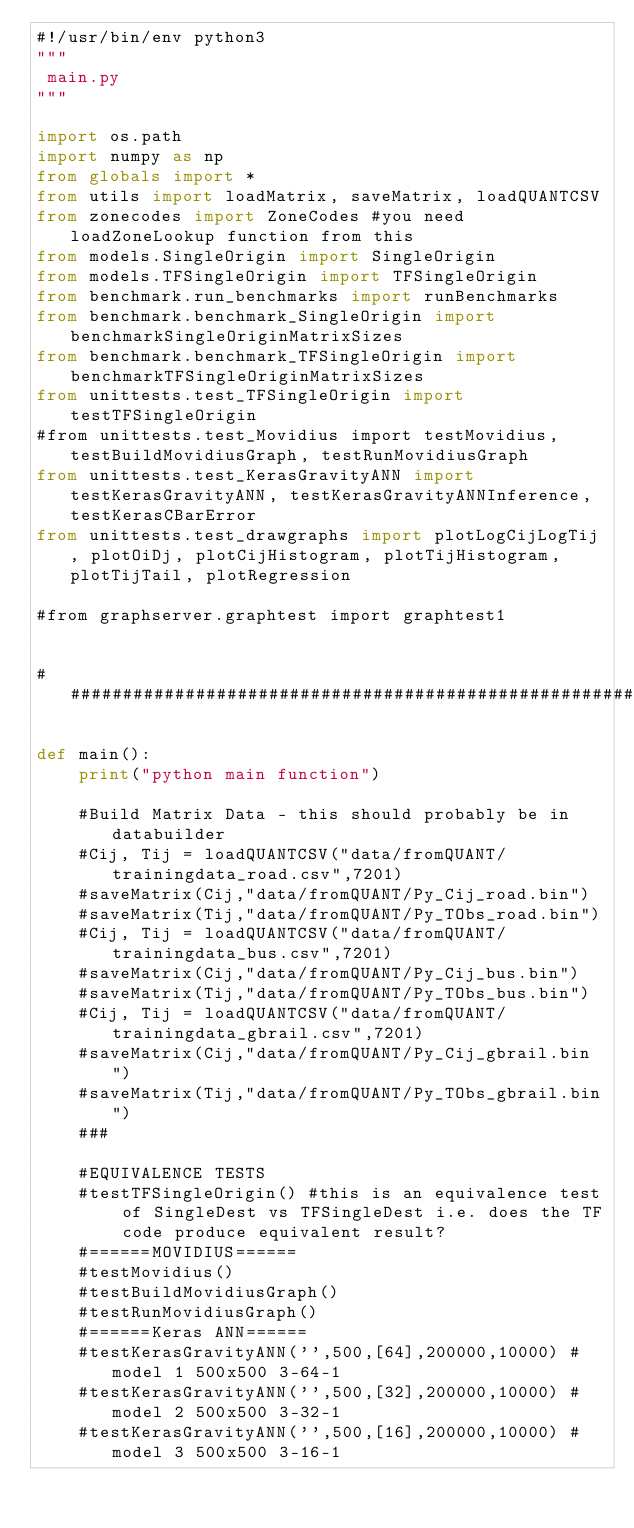Convert code to text. <code><loc_0><loc_0><loc_500><loc_500><_Python_>#!/usr/bin/env python3
"""
 main.py
"""

import os.path
import numpy as np
from globals import *
from utils import loadMatrix, saveMatrix, loadQUANTCSV
from zonecodes import ZoneCodes #you need loadZoneLookup function from this
from models.SingleOrigin import SingleOrigin
from models.TFSingleOrigin import TFSingleOrigin
from benchmark.run_benchmarks import runBenchmarks
from benchmark.benchmark_SingleOrigin import benchmarkSingleOriginMatrixSizes
from benchmark.benchmark_TFSingleOrigin import benchmarkTFSingleOriginMatrixSizes
from unittests.test_TFSingleOrigin import testTFSingleOrigin
#from unittests.test_Movidius import testMovidius, testBuildMovidiusGraph, testRunMovidiusGraph
from unittests.test_KerasGravityANN import testKerasGravityANN, testKerasGravityANNInference, testKerasCBarError
from unittests.test_drawgraphs import plotLogCijLogTij, plotOiDj, plotCijHistogram, plotTijHistogram, plotTijTail, plotRegression

#from graphserver.graphtest import graphtest1


###############################################################################

def main():
    print("python main function")

    #Build Matrix Data - this should probably be in databuilder
    #Cij, Tij = loadQUANTCSV("data/fromQUANT/trainingdata_road.csv",7201)
    #saveMatrix(Cij,"data/fromQUANT/Py_Cij_road.bin")
    #saveMatrix(Tij,"data/fromQUANT/Py_TObs_road.bin")
    #Cij, Tij = loadQUANTCSV("data/fromQUANT/trainingdata_bus.csv",7201)
    #saveMatrix(Cij,"data/fromQUANT/Py_Cij_bus.bin")
    #saveMatrix(Tij,"data/fromQUANT/Py_TObs_bus.bin")
    #Cij, Tij = loadQUANTCSV("data/fromQUANT/trainingdata_gbrail.csv",7201)
    #saveMatrix(Cij,"data/fromQUANT/Py_Cij_gbrail.bin")
    #saveMatrix(Tij,"data/fromQUANT/Py_TObs_gbrail.bin")
    ###

    #EQUIVALENCE TESTS
    #testTFSingleOrigin() #this is an equivalence test of SingleDest vs TFSingleDest i.e. does the TF code produce equivalent result?
    #======MOVIDIUS======
    #testMovidius()
    #testBuildMovidiusGraph()
    #testRunMovidiusGraph()
    #======Keras ANN======
    #testKerasGravityANN('',500,[64],200000,10000) #model 1 500x500 3-64-1
    #testKerasGravityANN('',500,[32],200000,10000) #model 2 500x500 3-32-1
    #testKerasGravityANN('',500,[16],200000,10000) #model 3 500x500 3-16-1</code> 